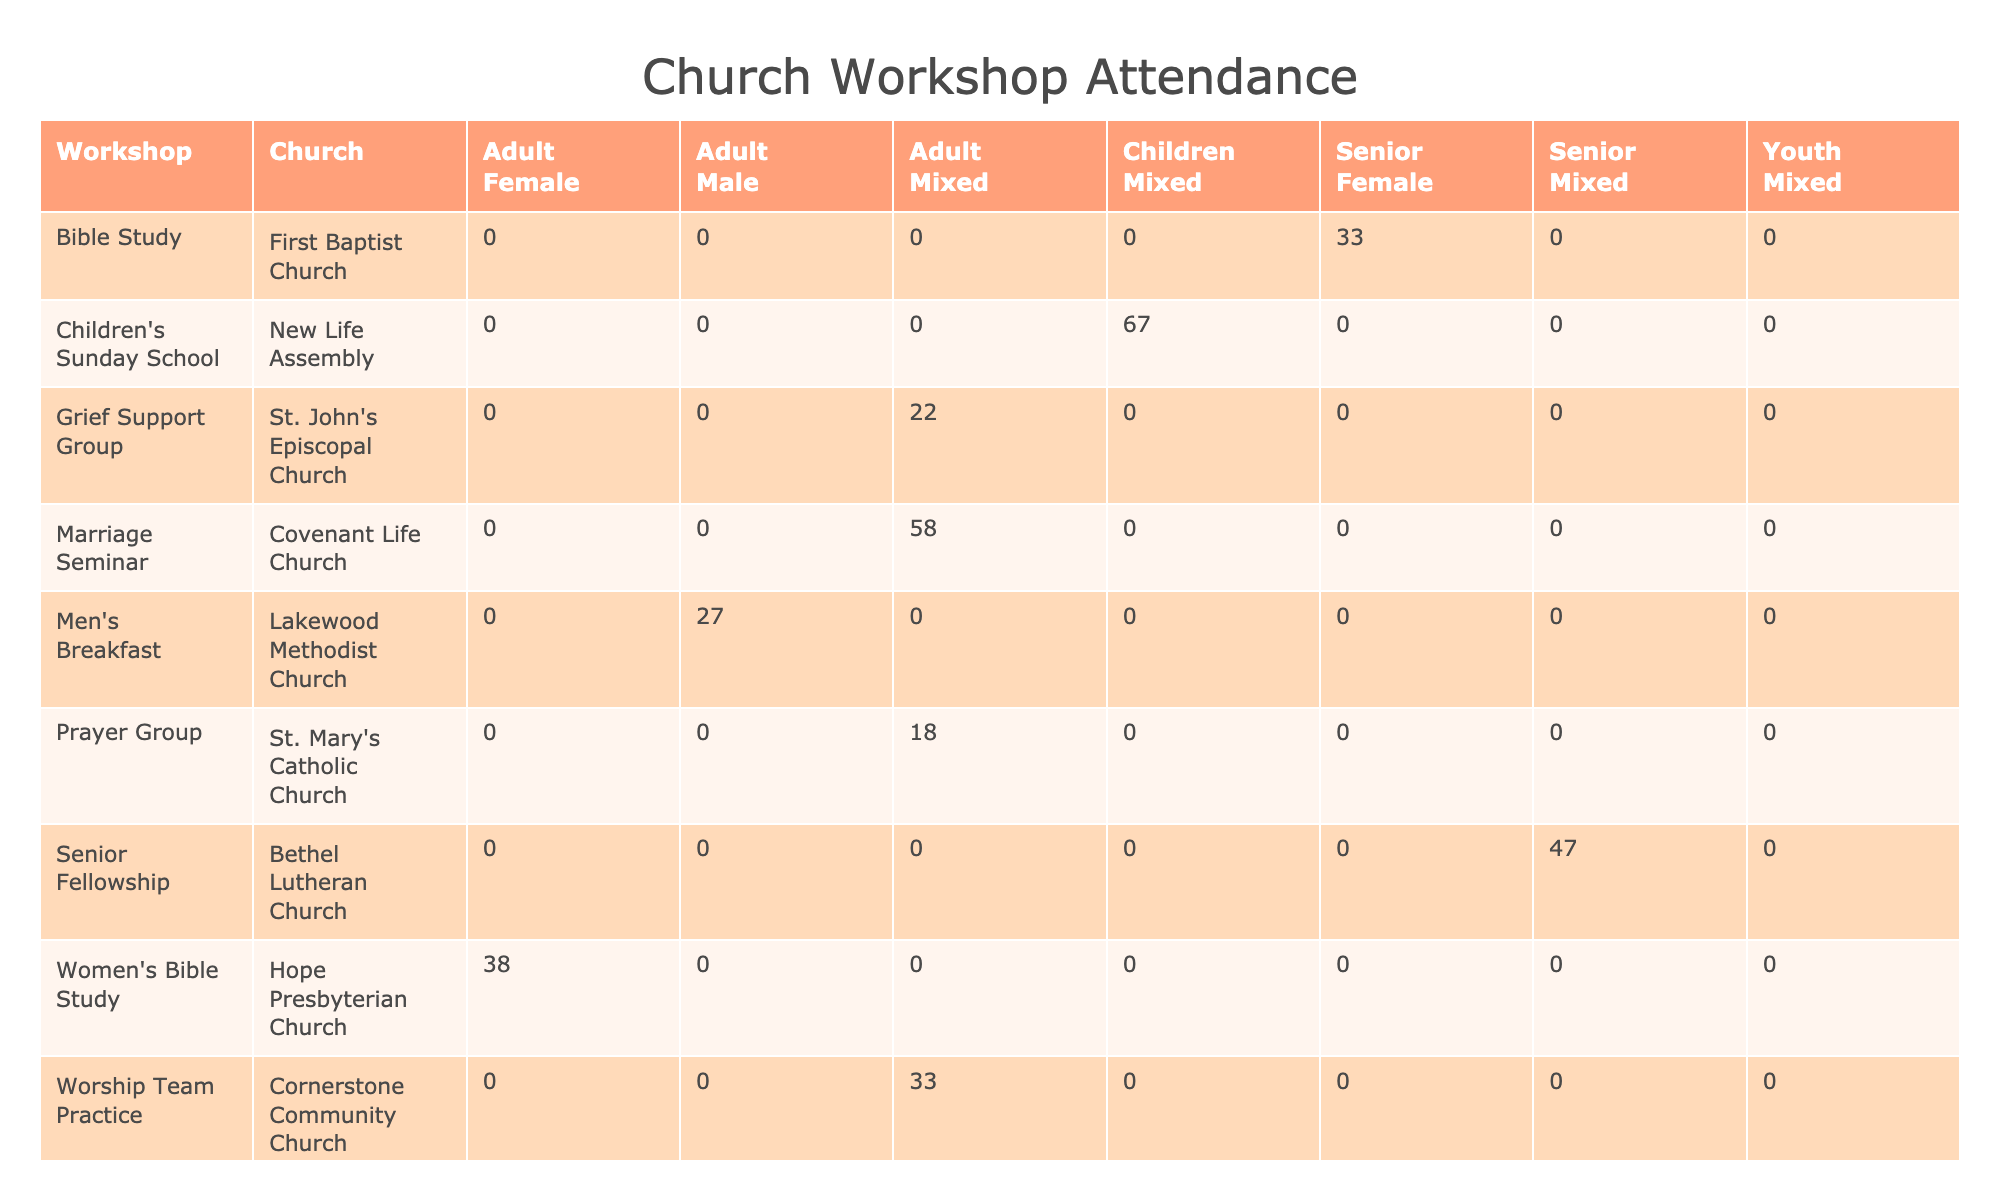What is the total attendance for the Children's Sunday School? To find the total attendance for the Children's Sunday School, we look at the rows corresponding to this workshop in the table. There are two entries with 35 and 32 attendees, respectively, so we add these numbers: 35 + 32 = 67.
Answer: 67 Which church had the highest attendance and what was the number? We compare the attendance numbers from all workshops across different churches. The Marriage Seminar at Covenant Life Church had the highest attendance with 30 attendees for the first occurrence and 28 attendees for the second occurrence. Therefore, the highest attendance found is 30.
Answer: 30 Did the Prayer Group have a consistent attendance regardless of church? To answer this, we look at the attendance figures for the Prayer Group. It had 8 attendees at St. Mary's Catholic Church and 10 attendees in a later meeting. Since these two values differ, we can conclude that attendance was not consistent.
Answer: No How many attendees were there across all workshops for the Adult age group? We need to sum the attendance for all workshops categorized under the Adult age group. The relevant entries are: Prayer Group (8 + 10), Marriage Seminar (30 + 28), Men's Breakfast (12 + 15), Women's Bible Study (18 + 20), Grief Support Group (10 + 12), Worship Team Practice (15 + 18). The total calculation becomes: 8 + 10 + 30 + 28 + 12 + 15 + 18 + 20 + 10 + 12 = 163. Thus, the overall total for the Adult age group is 163.
Answer: 163 How many workshops were conducted on a weekly basis? We can identify all workshops marked as "Weekly" in the frequency column. From the data, the workshops with weekly frequency are Bible Study, Youth Fellowship, Women's Bible Study, Children's Sunday School, and Worship Team Practice, which totals 5 workshops.
Answer: 5 